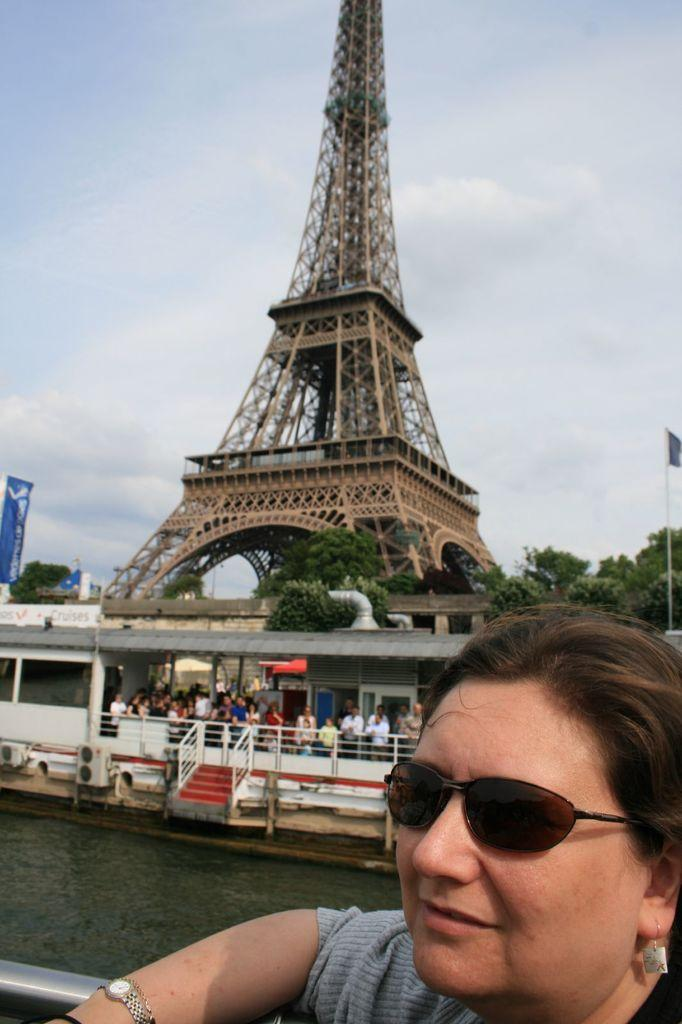What is the main structure in the image? There is a tower in the image. What other elements can be seen in the image? There are trees, people, and a banner with text. Can you describe the woman in the image? A woman is wearing sunglasses in the image. What is the weather like in the image? The sky is cloudy in the image. What type of government is depicted in the image? There is no depiction of a government in the image; it features a tower, trees, people, a woman wearing sunglasses, a banner with text, and a cloudy sky. Is there a church visible in the image? There is no church present in the image. 